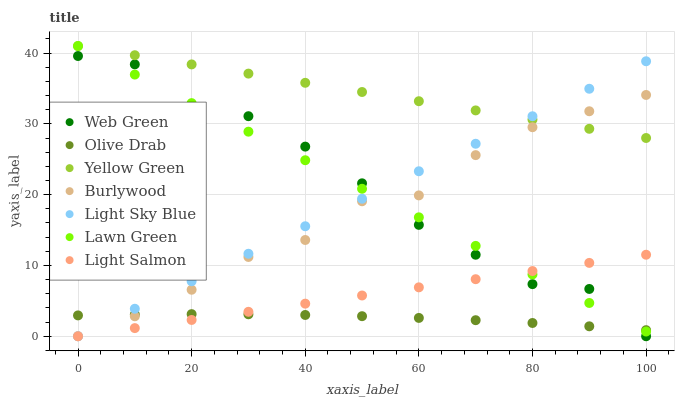Does Olive Drab have the minimum area under the curve?
Answer yes or no. Yes. Does Yellow Green have the maximum area under the curve?
Answer yes or no. Yes. Does Light Salmon have the minimum area under the curve?
Answer yes or no. No. Does Light Salmon have the maximum area under the curve?
Answer yes or no. No. Is Light Salmon the smoothest?
Answer yes or no. Yes. Is Web Green the roughest?
Answer yes or no. Yes. Is Yellow Green the smoothest?
Answer yes or no. No. Is Yellow Green the roughest?
Answer yes or no. No. Does Light Salmon have the lowest value?
Answer yes or no. Yes. Does Yellow Green have the lowest value?
Answer yes or no. No. Does Yellow Green have the highest value?
Answer yes or no. Yes. Does Light Salmon have the highest value?
Answer yes or no. No. Is Light Salmon less than Yellow Green?
Answer yes or no. Yes. Is Yellow Green greater than Olive Drab?
Answer yes or no. Yes. Does Olive Drab intersect Web Green?
Answer yes or no. Yes. Is Olive Drab less than Web Green?
Answer yes or no. No. Is Olive Drab greater than Web Green?
Answer yes or no. No. Does Light Salmon intersect Yellow Green?
Answer yes or no. No. 